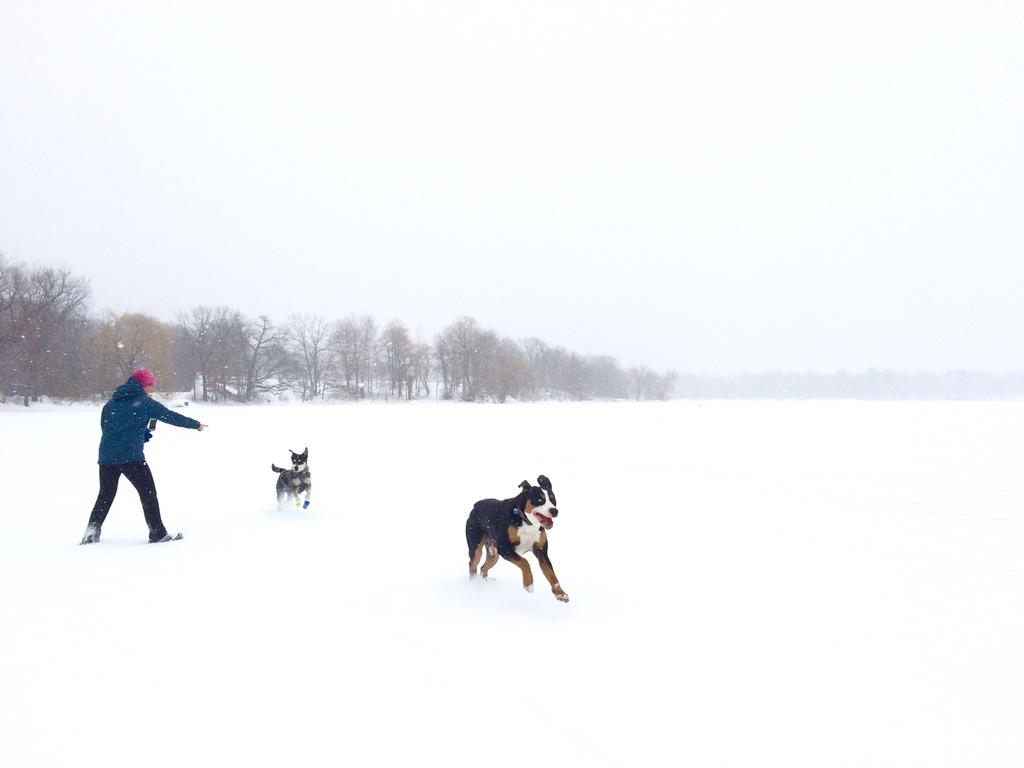How many dogs are present in the image? There are two dogs in the image. What is located on the left side of the image? There is a lady and trees on the left side of the image. What is the ground made of in the image? The ground is covered in snow at the bottom side of the image. Can you see any wounds on the dogs in the image? There is no indication of any wounds on the dogs in the image. What type of mitten is the lady wearing in the image? There is no mitten visible in the image, as the lady is not wearing any gloves or mittens. 